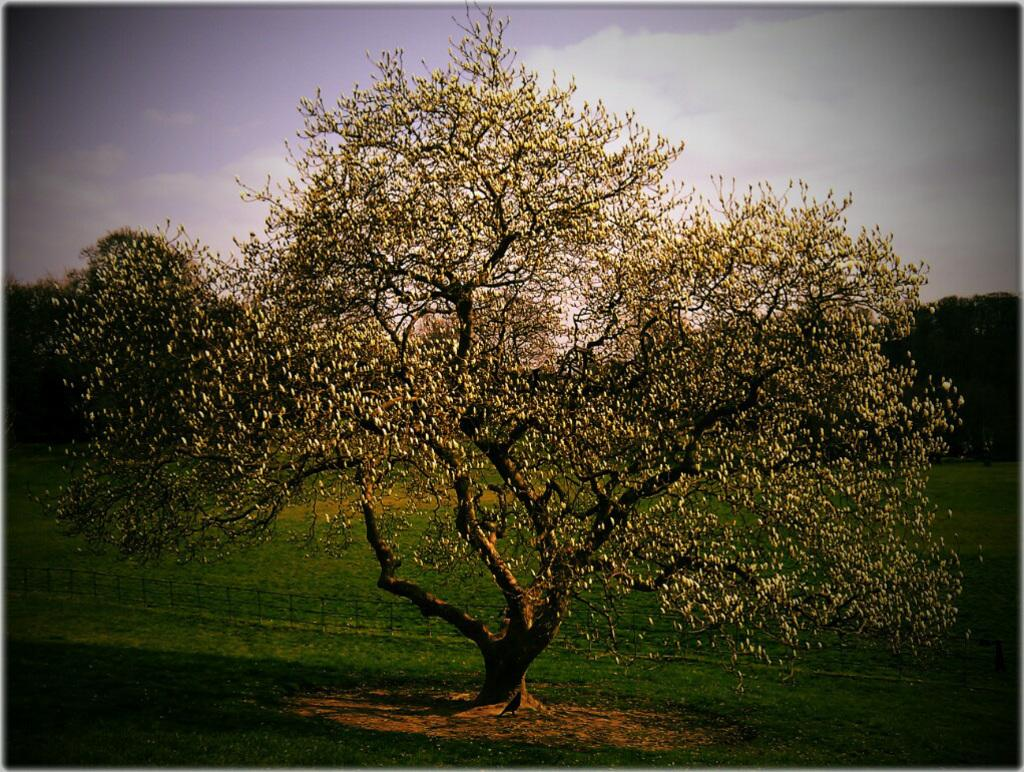What type of vegetation can be seen in the image? There are trees in the image. What is located in the foreground of the image? There is a fence in the foreground of the image. Can you describe the bird in the image? There is a bird under a tree in the image. What is visible at the top of the image? The sky is visible at the top of the image. What can be seen in the sky? There are clouds in the sky. What type of ground cover is present at the bottom of the image? Grass is present at the bottom of the image. What type of digestion can be observed in the image? There is no digestion present in the image; it features trees, a fence, a bird, the sky, clouds, and grass. How many planes are visible in the image? There are no planes visible in the image. 